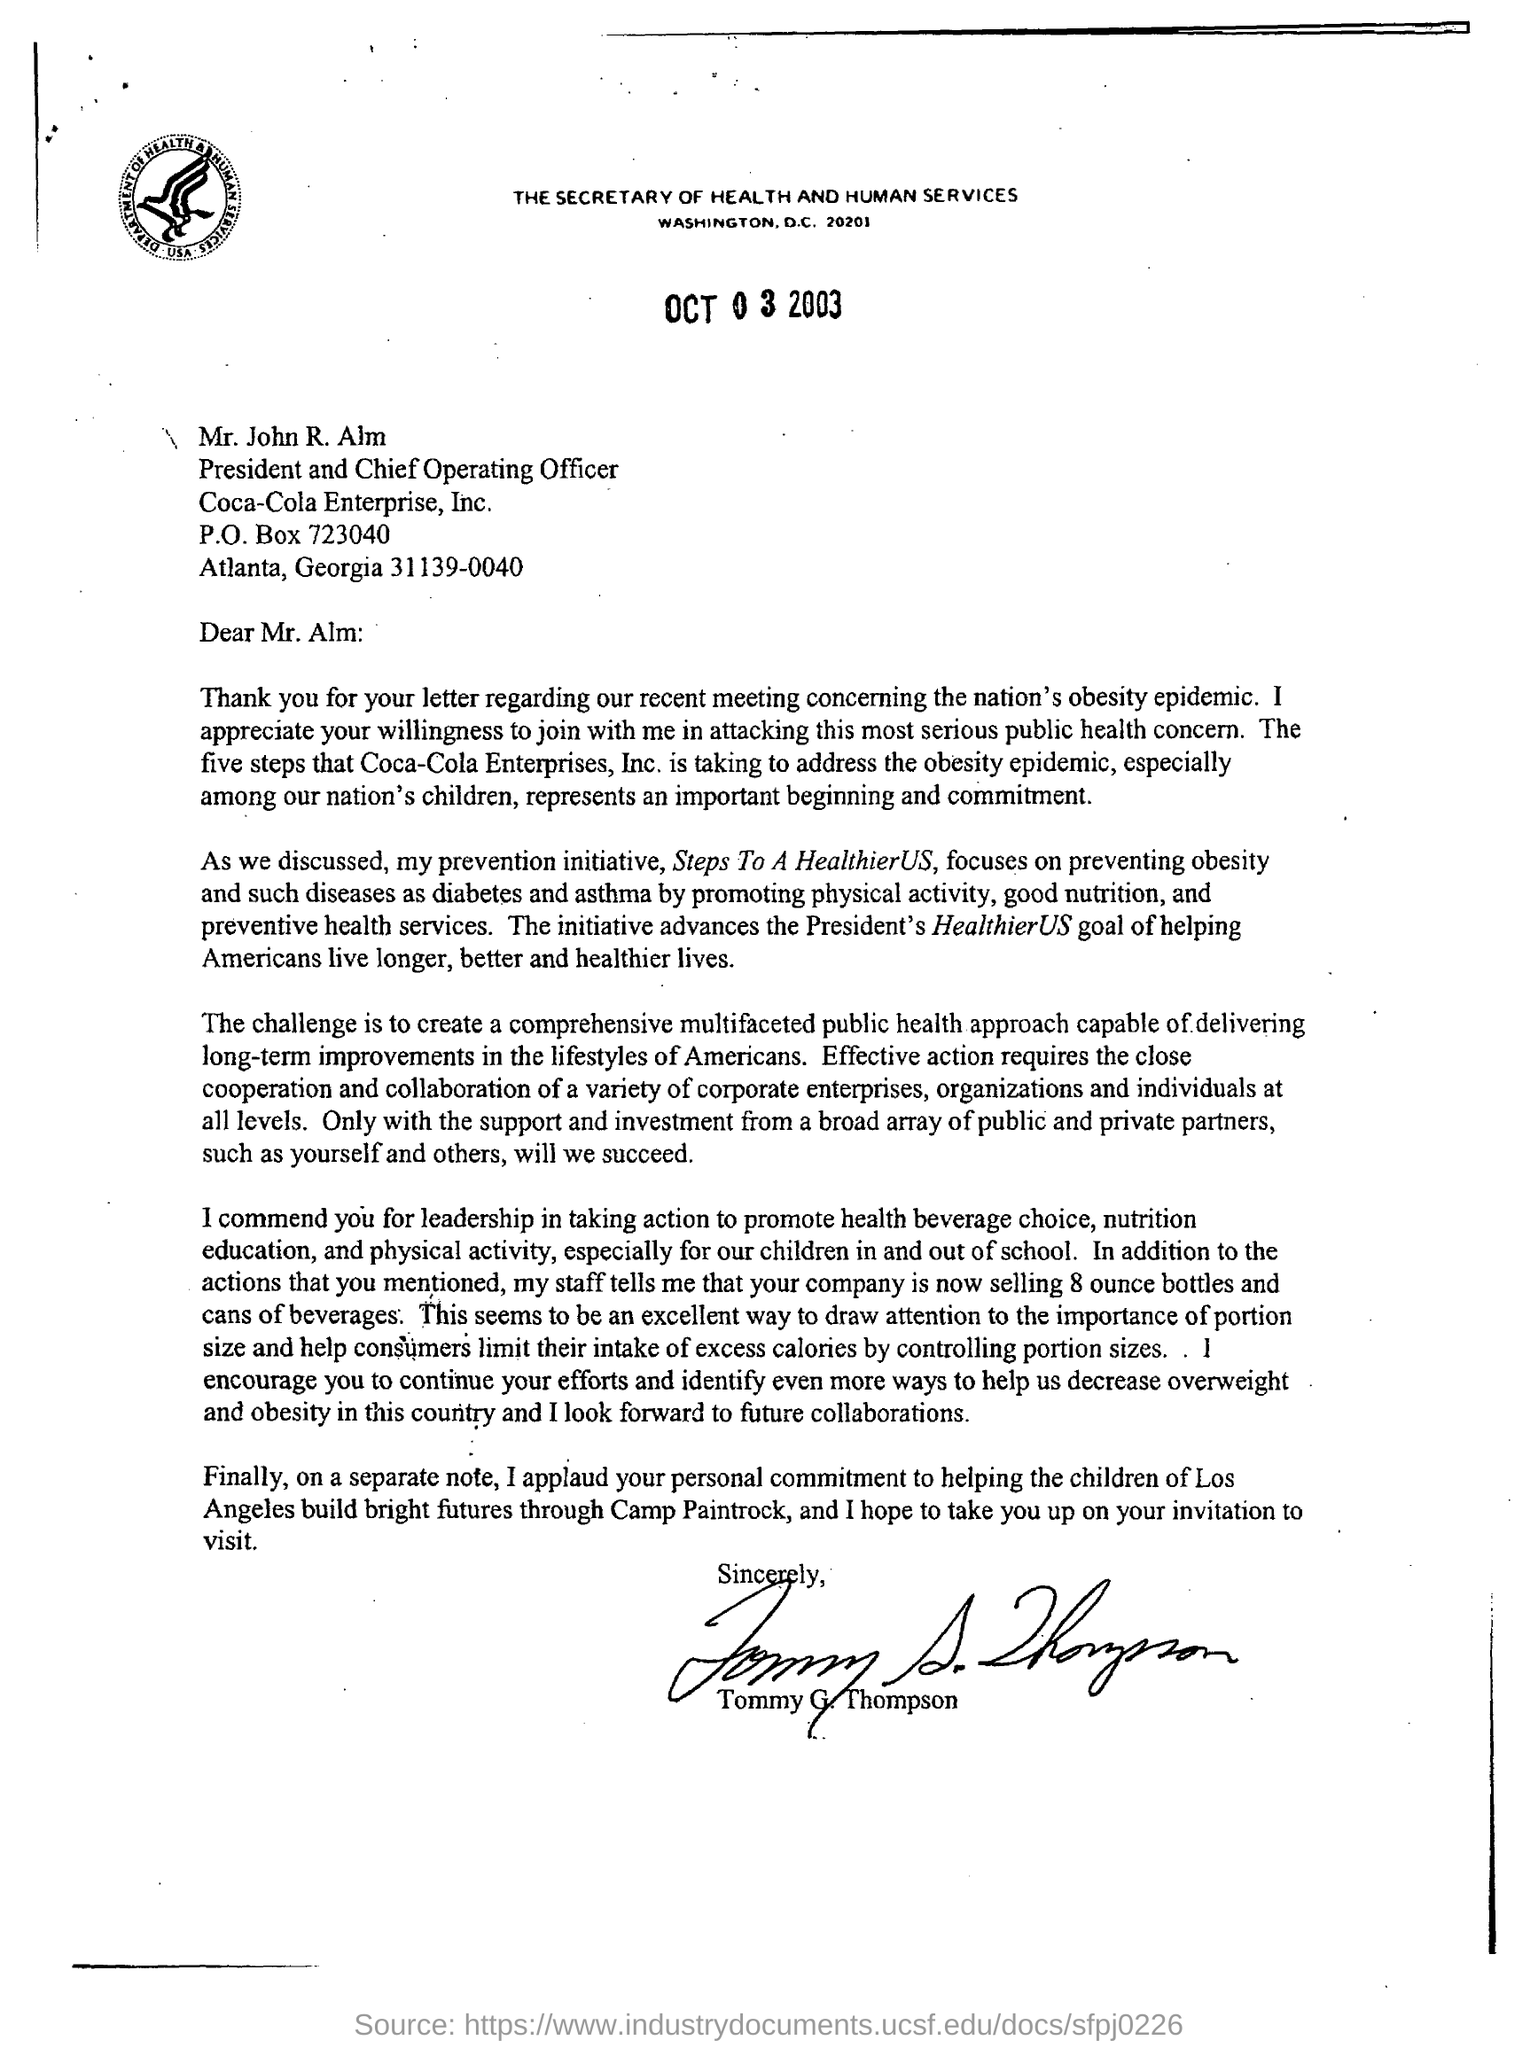Who is this letter sent to?
Your answer should be very brief. Mr. Alm. What is the designation of mr.john r alm?
Provide a succinct answer. President and Chief Operating Officer. What is the president's healthierus goal ?
Keep it short and to the point. Helping americans live longer, better and healthier lives. What is the reason to applaud alm?
Your answer should be very brief. Personal commitment to helping the children of los angeles build bright futures through camp paintrock. 